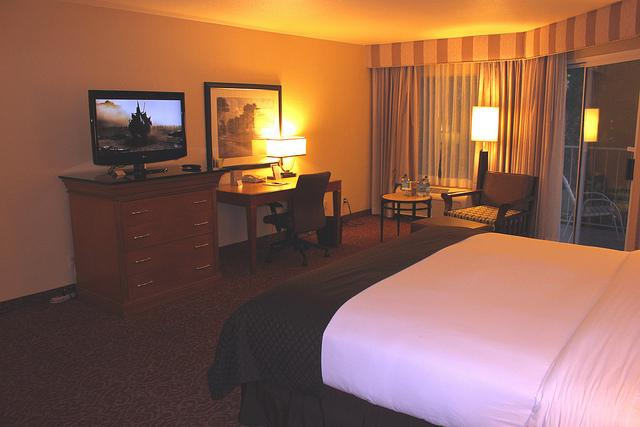What are in the bottles on the right?

Choices:
A) wine
B) water
C) gin
D) beer water 